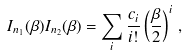<formula> <loc_0><loc_0><loc_500><loc_500>I _ { n _ { 1 } } ( \beta ) I _ { n _ { 2 } } ( \beta ) = \sum _ { i } \frac { c _ { i } } { i ! } \left ( \frac { \beta } { 2 } \right ) ^ { i } \, ,</formula> 